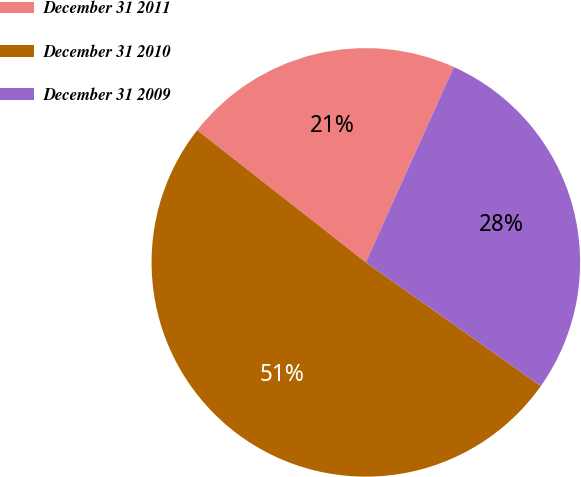Convert chart. <chart><loc_0><loc_0><loc_500><loc_500><pie_chart><fcel>December 31 2011<fcel>December 31 2010<fcel>December 31 2009<nl><fcel>21.16%<fcel>50.79%<fcel>28.05%<nl></chart> 